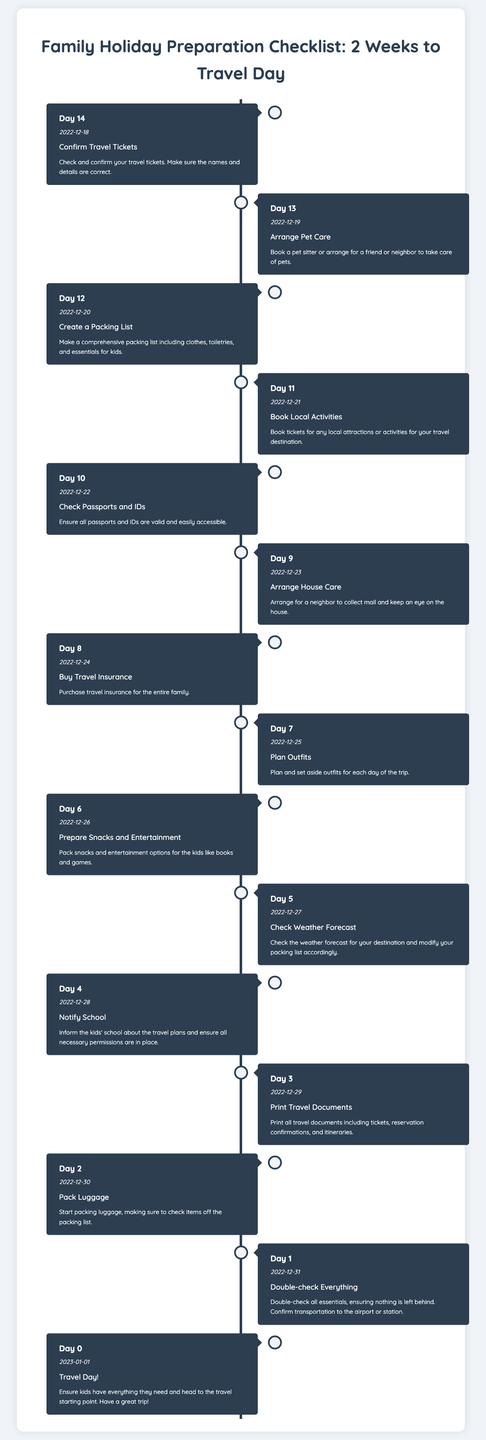What is the date for Day 10? The date for Day 10 is mentioned as 2022-12-22 in the document.
Answer: 2022-12-22 What task is scheduled for Day 5? The document lists the task for Day 5 as "Check Weather Forecast."
Answer: Check Weather Forecast How many days until travel day when confirming travel tickets? The task "Confirm Travel Tickets" is on Day 14, which is 14 days before the travel day.
Answer: 14 Which task comes before "Pack Luggage"? The task immediately before "Pack Luggage" is "Print Travel Documents" scheduled for Day 3.
Answer: Print Travel Documents What is the last task mentioned in the timeline? The last task is "Travel Day!" which occurs on Day 0.
Answer: Travel Day! What should be arranged on Day 13? The task for Day 13 is to "Arrange Pet Care."
Answer: Arrange Pet Care How many tasks need to be completed before the travel day? Counting down from Day 14 to Day 1, there are 14 tasks to complete before the travel day.
Answer: 14 Which day is designated for double-checking everything? "Double-check Everything" is designated for Day 1 in the timeline.
Answer: Day 1 What is emphasized for Day 4? On Day 4, it is emphasized to "Notify School."
Answer: Notify School 